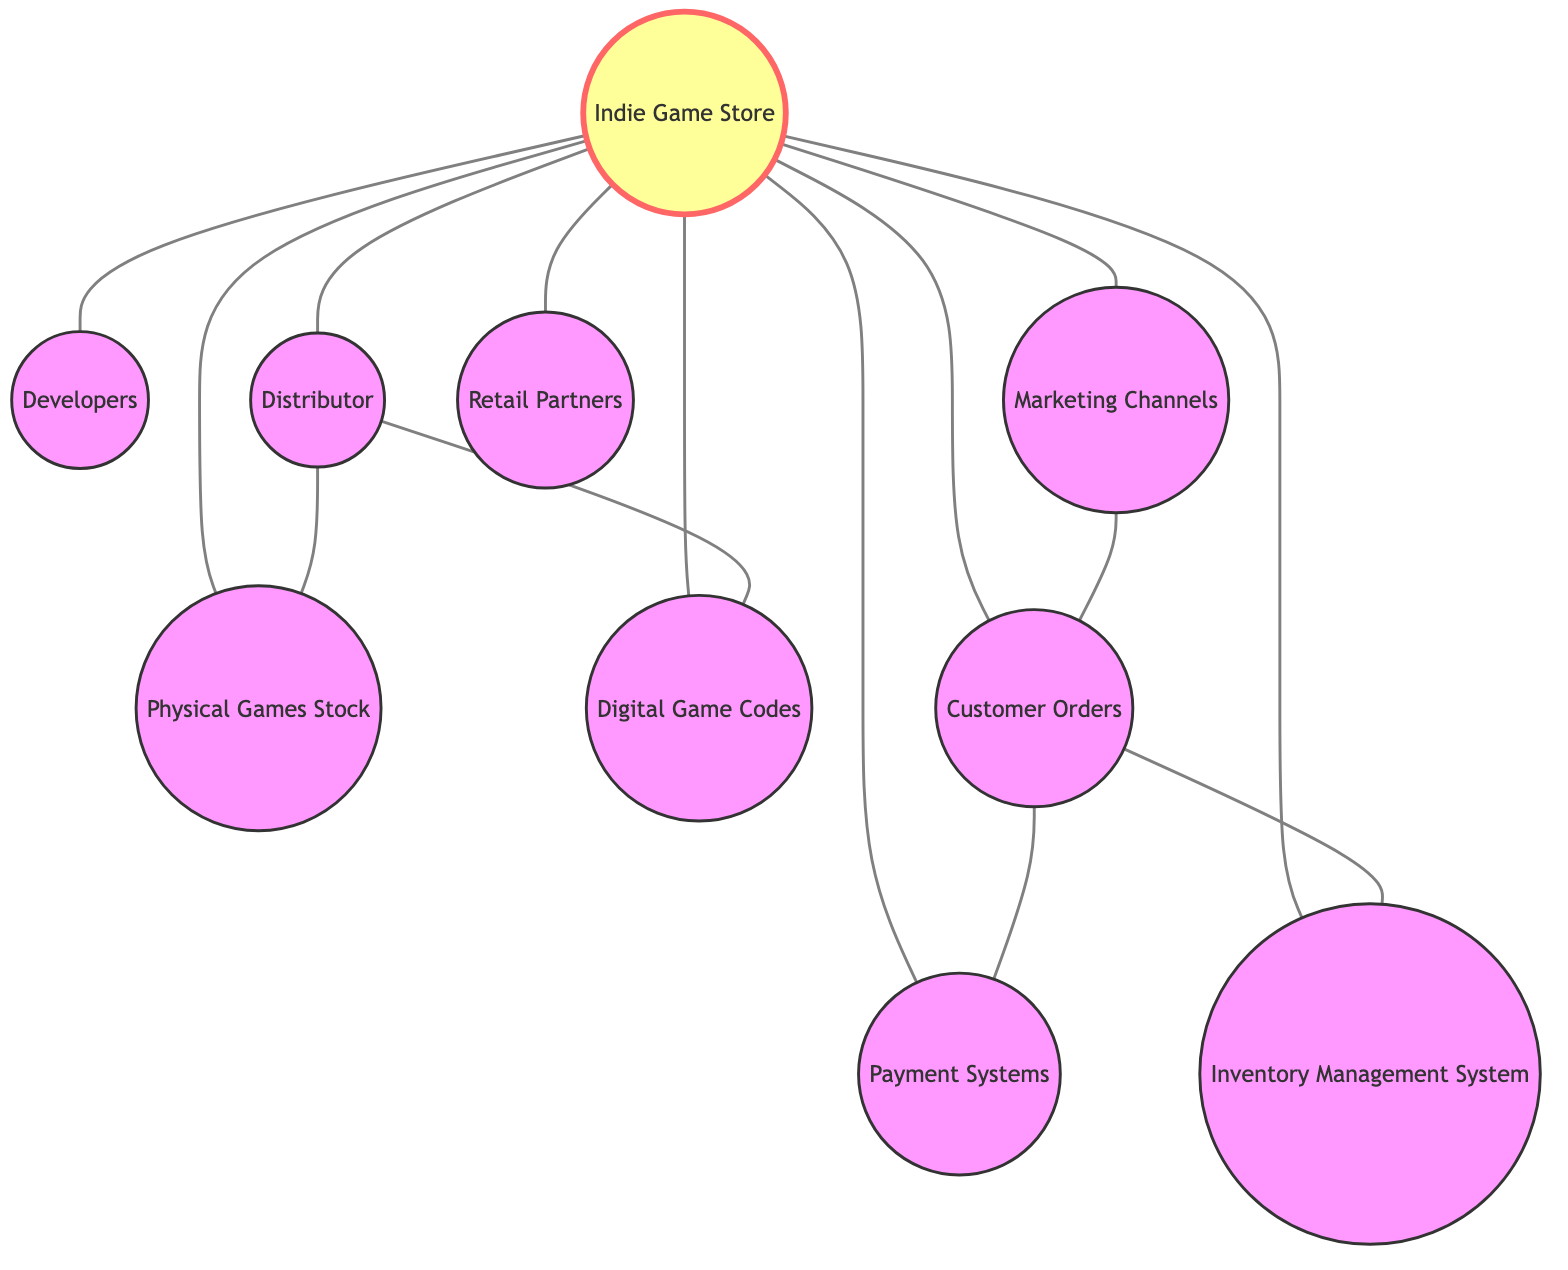What's the total number of nodes in the graph? The graph data indicates there are ten nodes, as given under "nodes".
Answer: 10 How many edges are connected to the Indie Game Store? The Indie Game Store is connected to nine other nodes by edges, as seen in the edges list.
Answer: 9 Which node is directly connected to both Developers and Customer Orders? The Indie Game Store connects directly to Developers and Customer Orders, as it is a central node in the diagram.
Answer: Indie Game Store What type of games does the Distributor supply? The Distributor supplies Physical Games Stock and Digital Game Codes, as indicated by the edges connecting them.
Answer: Physical Games Stock and Digital Game Codes How many nodes are there that receive connections from Marketing Channels? The Marketing Channels connect to one node, which is Customer Orders.
Answer: 1 What relationship exists between Customer Orders and Payment Systems? There is a direct connection or edge between Customer Orders and Payment Systems, showing they are linked.
Answer: Direct connection Which two nodes does the Distributor connect to? The Distributor connects to Physical Games Stock and Digital Game Codes, as noted in the edges section detailing this relationship.
Answer: Physical Games Stock and Digital Game Codes Which node serves as a hub for interactions in the supply chain? The Indie Game Store serves as a hub, connecting to multiple nodes in the supply chain, indicating its central role.
Answer: Indie Game Store What is the edge connection between Marketing Channels and another node? The edge connection exists between Marketing Channels and Customer Orders, indicating a flow of information or sales leads.
Answer: Customer Orders How many nodes are linked to the Inventory Management System? The Inventory Management System is directly linked to two nodes: Customer Orders and Indie Game Store.
Answer: 2 